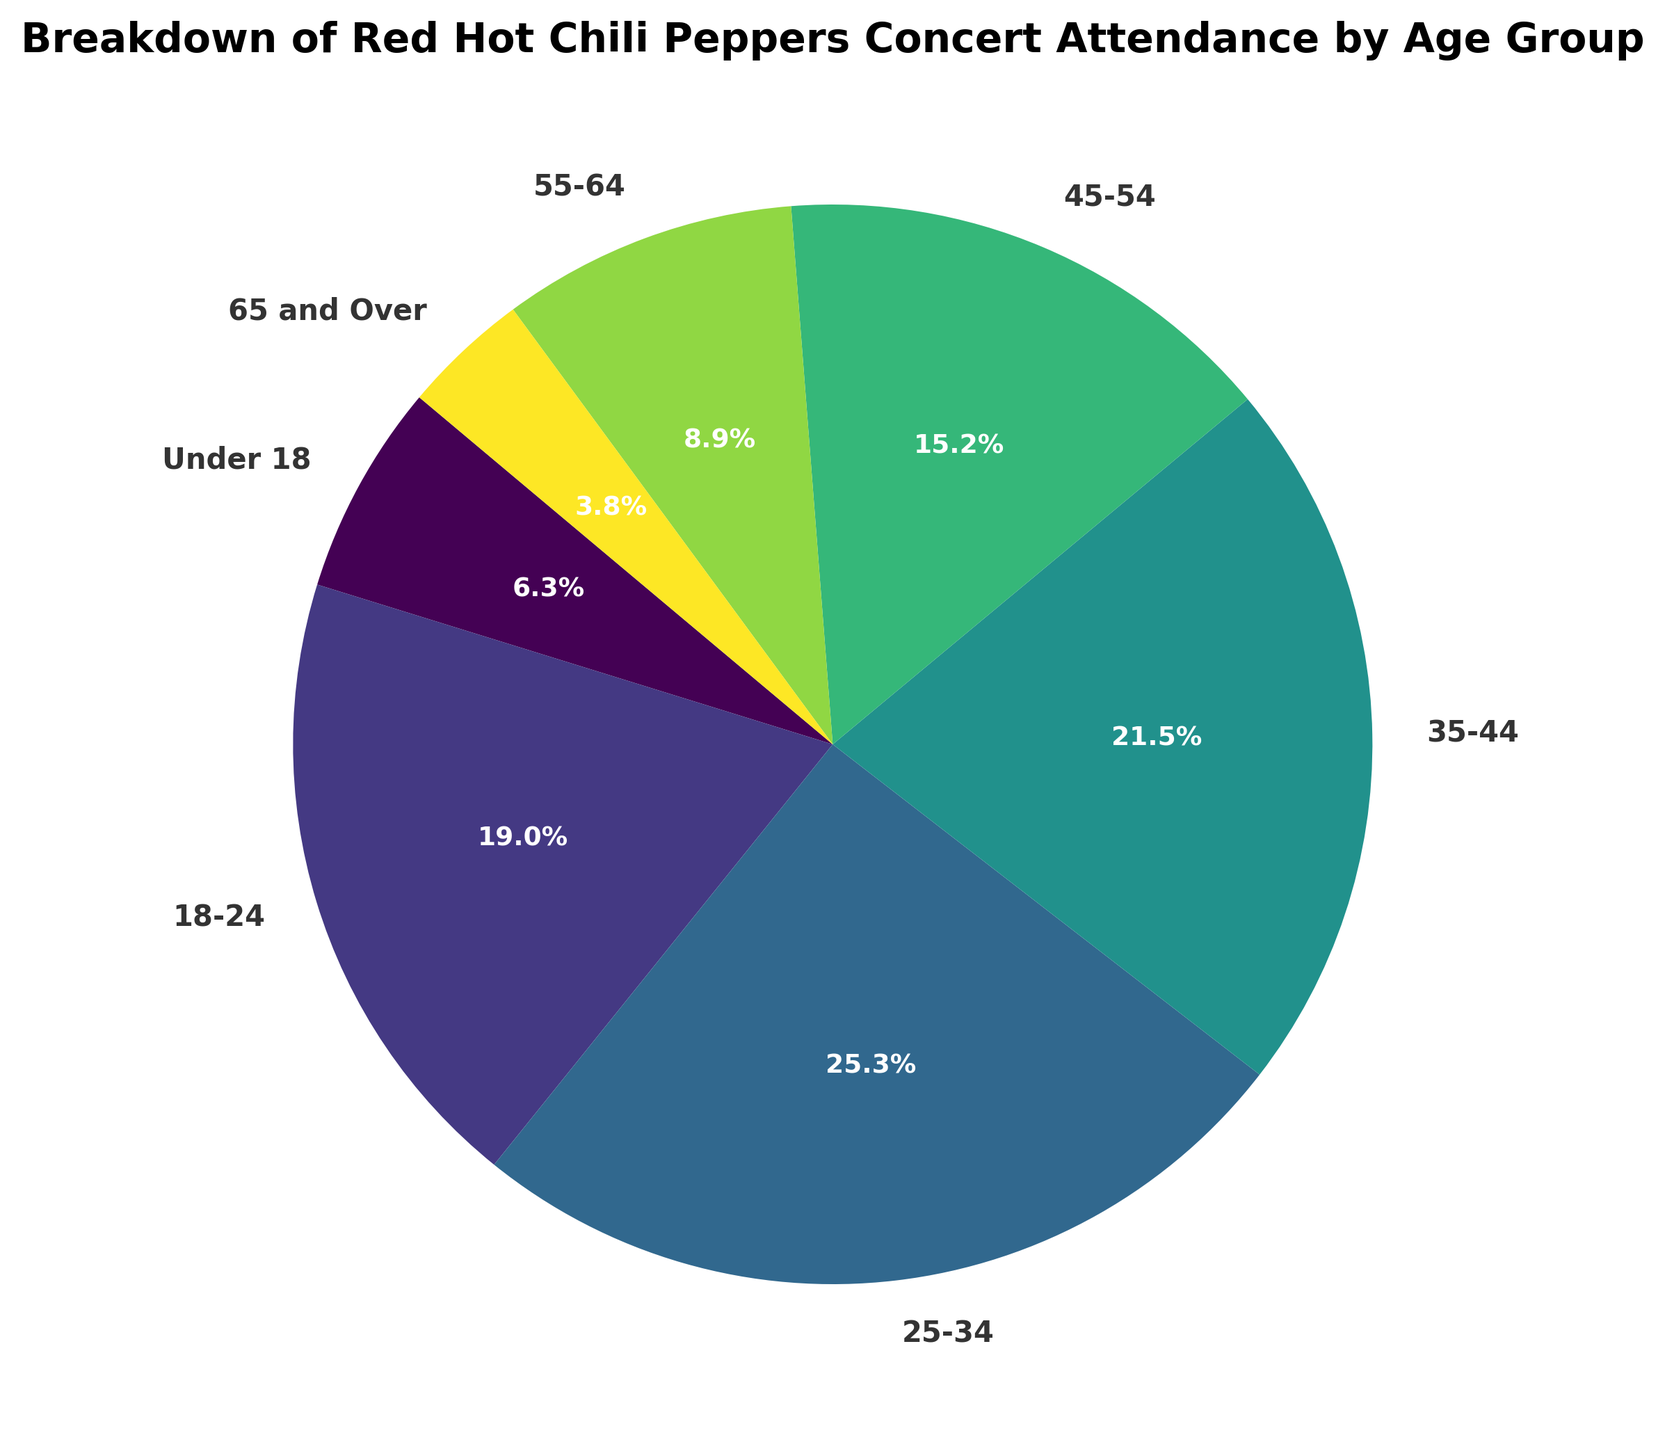What's the age group with the highest concert attendance? First, look at the proportions given in percentages on the pie chart for each age group. The age group with the largest percentage will be the one with the highest attendance. In this case, the 25-34 age group has the largest segment.
Answer: 25-34 Which age group attends Red Hot Chili Peppers' concerts the least? Similar to finding the highest, find the smallest percentage on the pie chart. The age group with the smallest segment is 65 and Over.
Answer: 65 and Over What is the total concert attendance for people aged 35 and over? Add the attendance numbers for the age groups 35-44, 45-54, 55-64, and 65 and Over. 17000 + 12000 + 7000 + 3000 = 39000
Answer: 39000 Which age group has more attendance: 18-24 or 45-54? Compare the attendance numbers for the 18-24 age group and the 45-54 age group. 15000 (18-24) is greater than 12000 (45-54).
Answer: 18-24 How much larger is the attendance of the 25-34 age group than the 45-54 age group? Subtract the attendance of the 45-54 age group from that of the 25-34 age group. 20000 - 12000 = 8000
Answer: 8000 Which age groups together form more than half of the total attendance? Calculate the total attendance which is 80000. Then find the combination of age groups whose summed attendance exceeds half of this total (40000). The age groups 18-24, 25-34, and 35-44 together sum to 52000, which is more than half.
Answer: 18-24, 25-34, 35-44 Which segment appears the smallest in size and what is its attendance? Visually identify the smallest segment on the pie chart, which is the 65 and Over age group. Its attendance is 3000.
Answer: 65 and Over, 3000 What is the combined attendance of the two largest age groups? Identify the two largest age groups by their percentages (25-34 and 35-44), then sum their respective attendances. 20000 + 17000 = 37000
Answer: 37000 By how much does the attendance of the 35-44 age group exceed that of the 55-64 age group? Subtract the attendance of the 55-64 age group from the 35-44 age group. 17000 - 7000 = 10000
Answer: 10000 What percent of total attendance is represented by people under 25? Add the attendance numbers for the age groups Under 18 (5000) and 18-24 (15000). The total attendance is 80000. Therefore, (5000 + 15000) / 80000 * 100 = 25%
Answer: 25% 